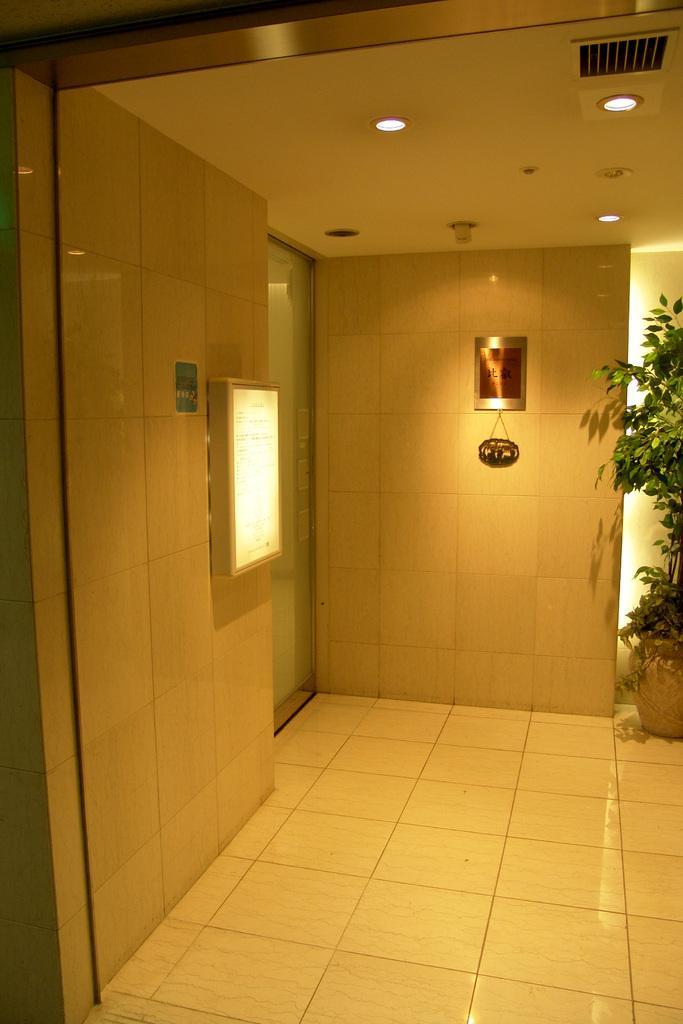Please provide a concise description of this image. In this image we can see walls, house plant and electric lights attached to the roof. 